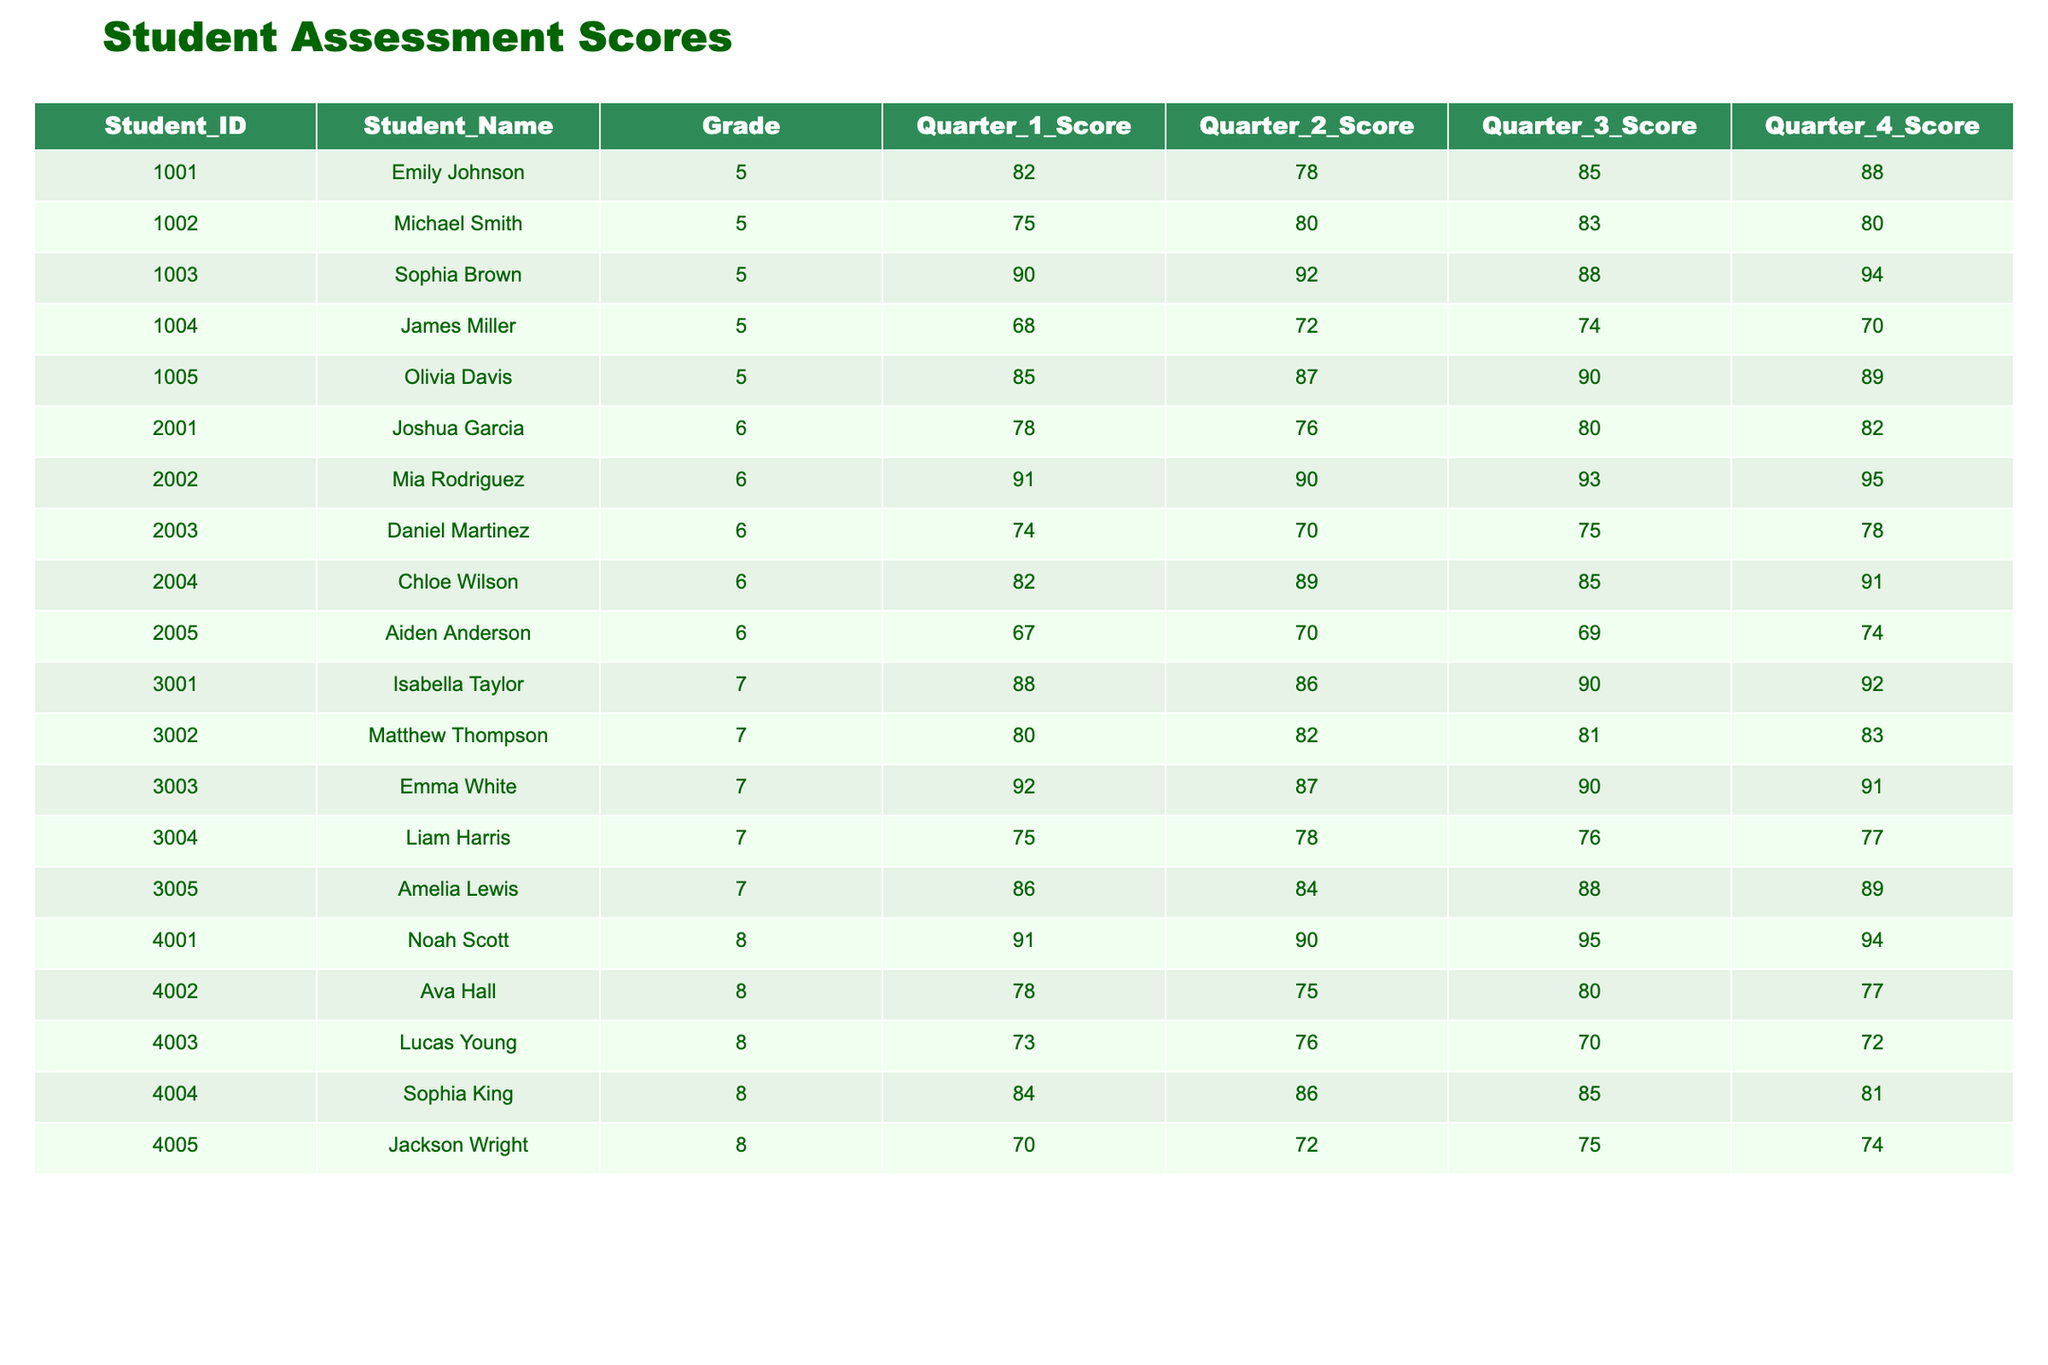What was Sophia Brown's Quarter 1 Score? Sophia Brown's Quarter 1 Score can be found in the table under the column "Quarter_1_Score" and the row corresponding to her entry. In the table, her score is listed as 90.
Answer: 90 What is the average Quarter 3 score for students in Grade 6? To find the average Quarter 3 score for Grade 6 students, we sum the scores from the "Quarter_3_Score" column for students with Grade 6. The scores are 80, 93, 75, 85, and 69. Summing these gives 80 + 93 + 75 + 85 + 69 = 402. Since there are 5 students, we calculate the average as 402 / 5 = 80.4.
Answer: 80.4 Did Olivia Davis score higher than 85 in Quarter 4? To answer this, we check the "Quarter_4_Score" for Olivia Davis. In the table, her score is listed as 89. Since 89 is greater than 85, the answer is yes.
Answer: Yes Which student had the highest score in Quarter 2 among Grade 7 students? We look at the "Quarter_2_Score" for the student entries in Grade 7. The scores are 86, 82, 87, 78, and 84. The highest score is 87, which belongs to Emma White.
Answer: Emma White What is the difference between the highest Quarter 4 score and the lowest Quarter 4 score? First, we find the highest Quarter 4 score from the table. The scores are 88, 80, 91, 94, 77, and 74. The highest is 94 (Noah Scott) and the lowest is 74 (Jackson Wright). The difference is calculated as 94 - 74 = 20.
Answer: 20 How many students scored above 85 in Quarter 1? We examine the "Quarter_1_Score" column for all students. The scores above 85 belong to Sophia Brown (90), Olivia Davis (85), Isabella Taylor (88), and Noah Scott (91), totaling 4 students.
Answer: 4 Is Aiden Anderson’s score the lowest in Quarter 2? To verify this, we check Aiden Anderson’s Quarter 2 score of 70 against the other scores in that column: 76, 90, 70, 87, and 75. Since Aiden’s score is equal to the lowest score, the answer is yes.
Answer: Yes Which grade had the highest average score in Quarter 1? We compute the average for each grade in Quarter 1. For Grade 5: (82 + 75 + 90 + 68 + 85) / 5 = 80; Grade 6: (78 + 91 + 74 + 82 + 67) / 5 = 78.4; Grade 7: (88 + 80 + 92 + 75 + 86) / 5 = 84.2; Grade 8: (91 + 78 + 73 + 84 + 70) / 5 = 79.2. The highest average is for Grade 7 at 84.2.
Answer: Grade 7 What percentage of students scored lower than 80 in Quarter 3? We evaluate the "Quarter_3_Score" column, noting scores below 80: 74, 69, and 76 (totaling 3 students out of 20). To find the percentage, we calculate (3 / 20) * 100 = 15%.
Answer: 15% 